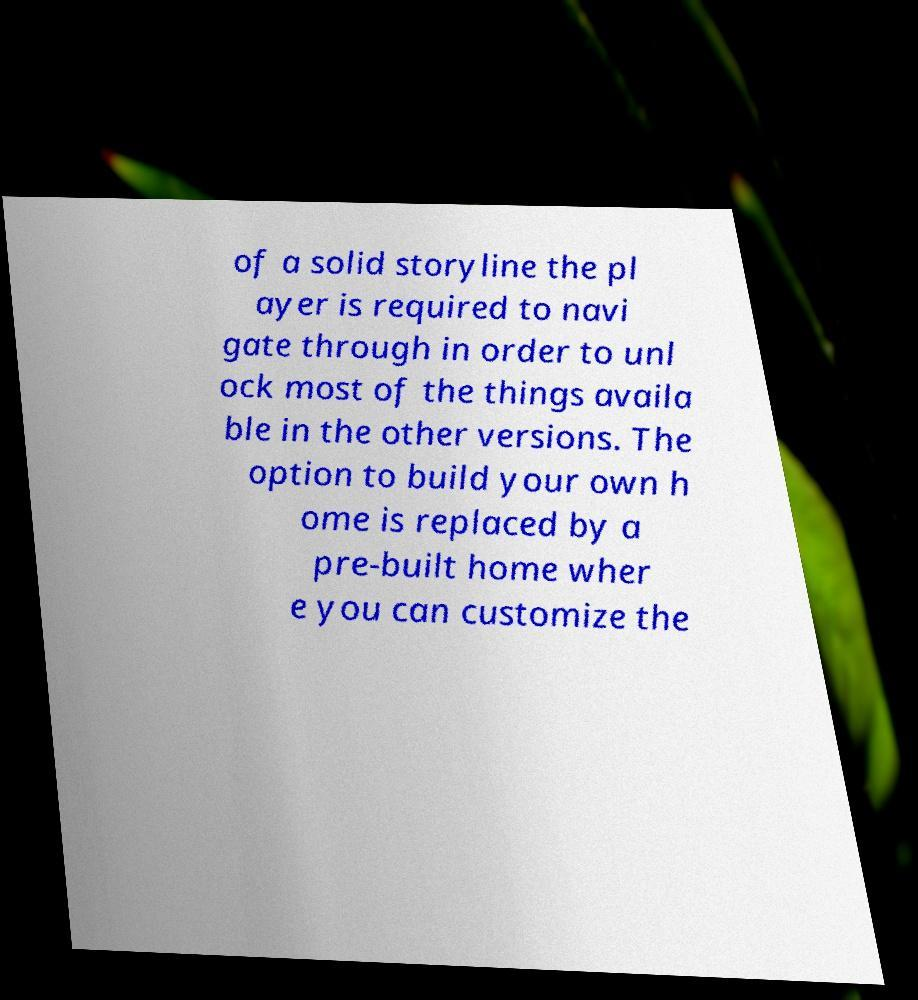What messages or text are displayed in this image? I need them in a readable, typed format. of a solid storyline the pl ayer is required to navi gate through in order to unl ock most of the things availa ble in the other versions. The option to build your own h ome is replaced by a pre-built home wher e you can customize the 